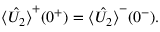Convert formula to latex. <formula><loc_0><loc_0><loc_500><loc_500>\begin{array} { r } { \hat { \langle U _ { 2 } \rangle } ^ { + } ( 0 ^ { + } ) = \hat { \langle U _ { 2 } \rangle } ^ { - } ( 0 ^ { - } ) . } \end{array}</formula> 